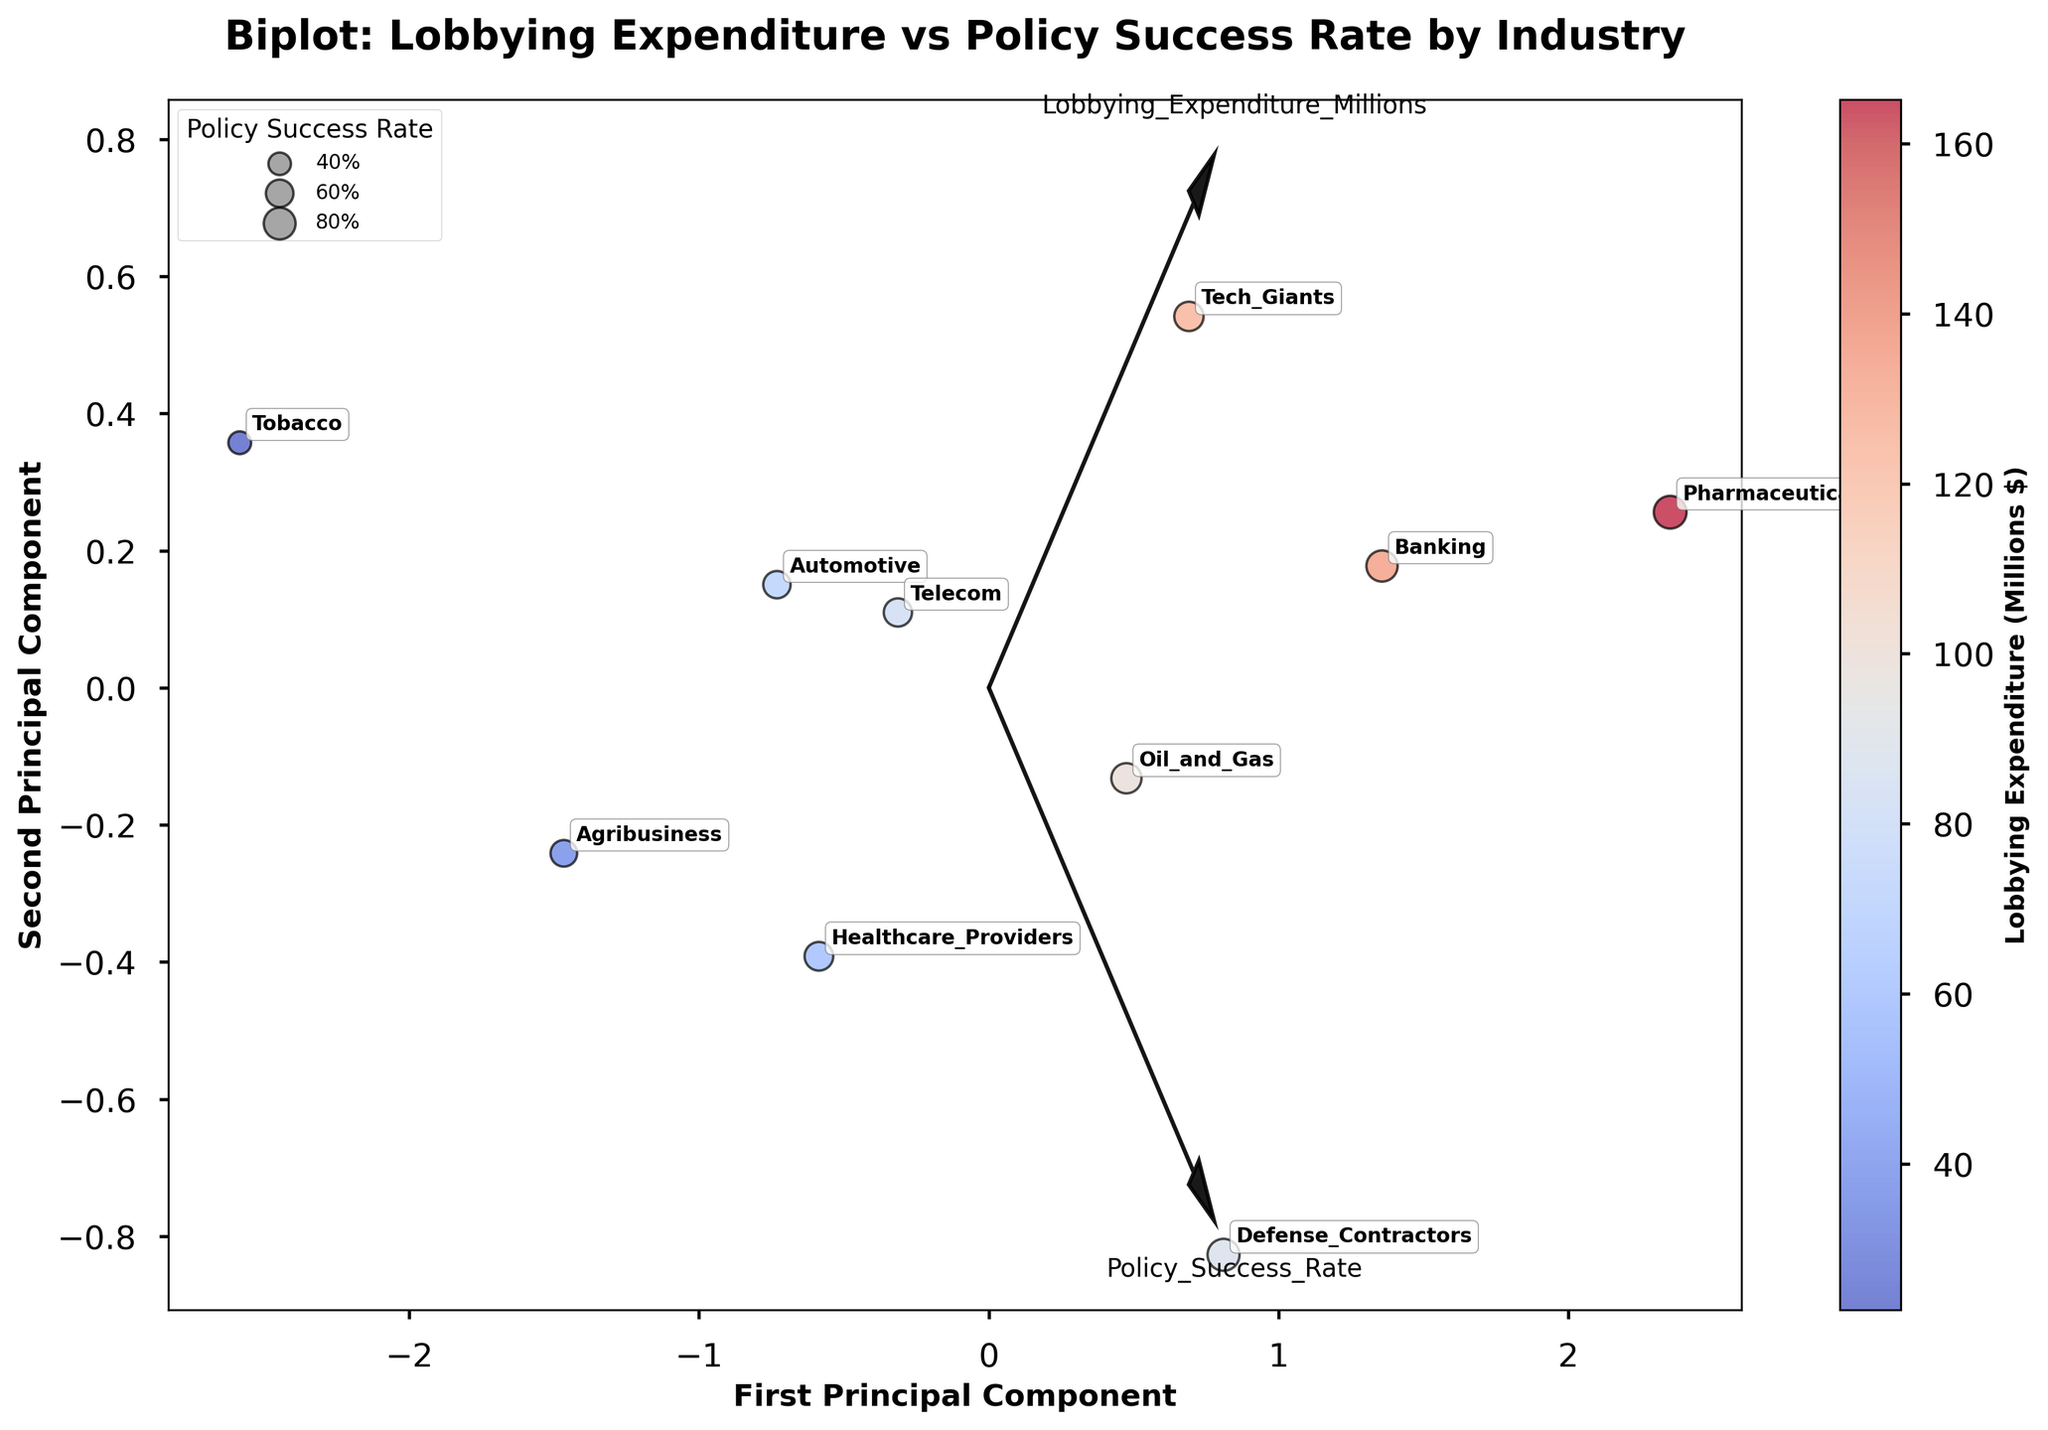What's the title of the figure? The title of the figure appears at the top of the plot. It clearly indicates what the plot is representing. From the given information, the title is: "Biplot: Lobbying Expenditure vs Policy Success Rate by Industry".
Answer: Biplot: Lobbying Expenditure vs Policy Success Rate by Industry How many industries are represented in the figure? The figure contains one data point per industry, thus counting the data points will give the number of industries represented. There are 10 data points in the figure.
Answer: 10 Which industry has the highest lobbying expenditure? By observing the colorbar and identifying the most intense color in the figure, we can determine the industry with the highest lobbying expenditure. From the given data, the industry with the highest lobbying expenditure is Pharmaceuticals.
Answer: Pharmaceuticals Which industry has the lowest policy success rate? To find the industry with the lowest policy success rate, we can refer to the size of the circles. Smaller circles represent lower policy success rates. From the given data, the Tobacco industry has the lowest policy success rate (0.41).
Answer: Tobacco Are there any industries with similar lobbying expenditures but different policy success rates? Comparing the positions of the data points (X and Y coordinates), we can identify industries with similar lobbying expenditures (similar X-axis placement) but different policy success rates (different bubble sizes). Telecom and Healthcare Providers have relatively similar lobbying expenditures but different policy success rates.
Answer: Telecom and Healthcare Providers What does the direction of the feature vectors indicate? The feature vectors (arrows) in a biplot indicate the direction of the variables in the PCA-transformed space. The direction suggests how each variable contributes to the components. For example, a more extended arrow generally indicates a stronger influence on the principal components. The arrows show the importance and conjunction of 'Lobbying Expenditure' and 'Policy Success Rate'.
Answer: Influence on PCA components Which industry has a policy success rate closest to 0.85? By examining the sizes of the circles closest to 0.85 on the size legend, we observe the Pharma industry has the closest policy success rate to 0.85.
Answer: Pharmaceuticals How does the Tech Industry compare to the Banking Industry in terms of lobbying expenditure and policy success rate? By comparing the position and size of the circles representing Tech Giants and Banking, we can analyze their relative lobby expenditures and success rates. From the given information, Tech Giants have lower lobbying expenditure (124.7) and a lower policy success rate (0.68) compared to Banking (133.6, 0.77).
Answer: Tech Giants < Banking in both Which principal component explains more variance in the data? In most PCA biplots, the axis with a larger spread of data points usually indicates higher variance. Considering the typical arrangement, the first principal component (X-axis) often captures the majority of the variance.
Answer: First Principal Component What does the colorbar in the figure represent? The colorbar on the side of the biplot indicates the intensity of the lobbying expenditure for the represented industries. Darker and more intense colors reflect higher lobbying expenditures.
Answer: Lobbying Expenditure 